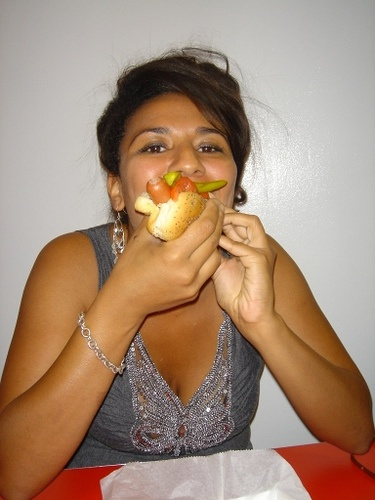Describe the objects in this image and their specific colors. I can see people in gray, brown, tan, and black tones, dining table in gray, brown, maroon, and lightpink tones, hot dog in gray, orange, khaki, and olive tones, and sandwich in gray, orange, and khaki tones in this image. 